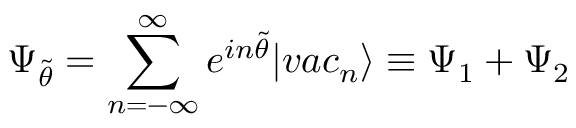<formula> <loc_0><loc_0><loc_500><loc_500>\Psi _ { \tilde { \theta } } = \sum _ { n = - \infty } ^ { \infty } e ^ { i n \tilde { \theta } } | v a c _ { n } \rangle \equiv \Psi _ { 1 } + \Psi _ { 2 }</formula> 